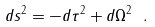<formula> <loc_0><loc_0><loc_500><loc_500>d s ^ { 2 } = - d \tau ^ { 2 } + d \Omega ^ { 2 } \ .</formula> 